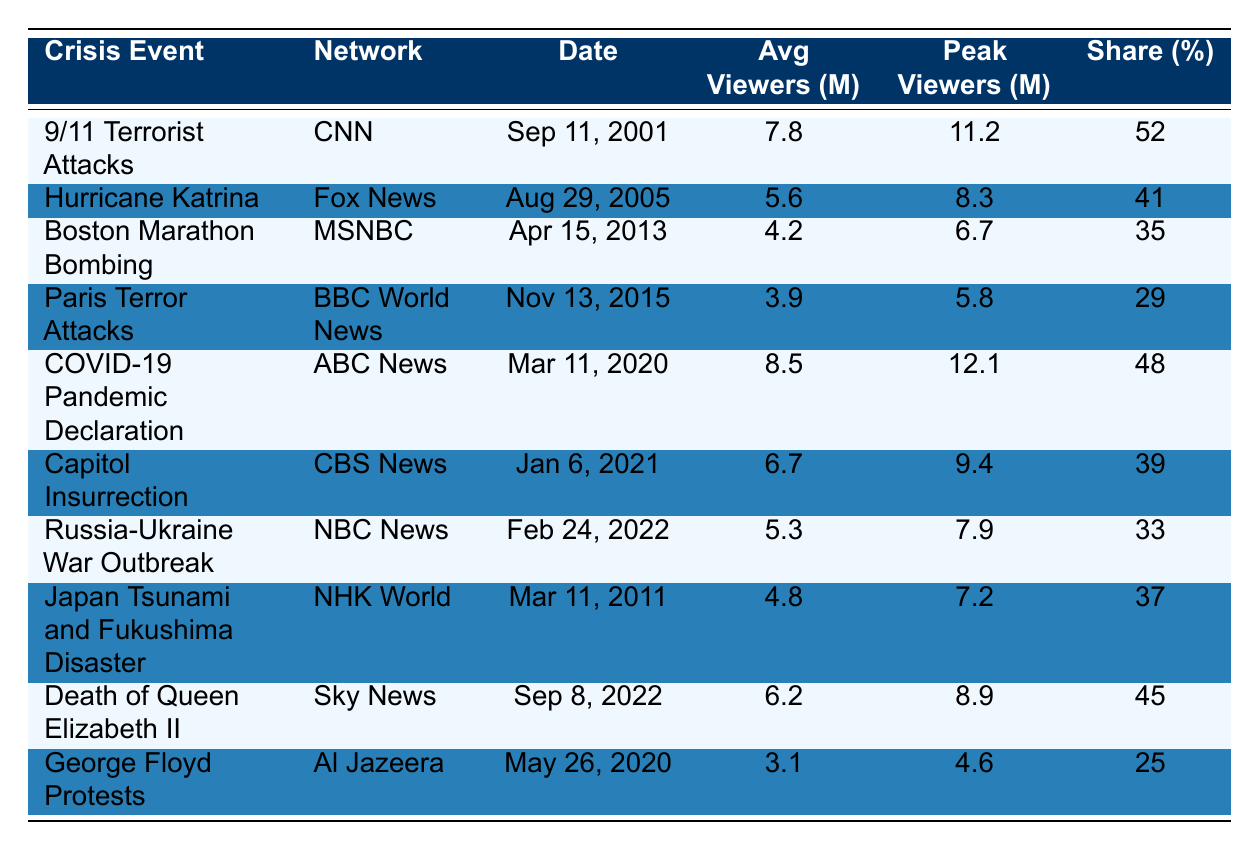What network had the highest average viewer count during a crisis event? According to the table, CNN had the highest average viewer count of 7.8 million during the 9/11 Terrorist Attacks.
Answer: CNN Which crisis event had the lowest peak viewers? The table shows that the George Floyd Protests had the lowest peak viewers at 4.6 million.
Answer: George Floyd Protests What is the average share percentage of viewers for all the crisis events listed? To find the average share percentage, add all the share values (52 + 41 + 35 + 29 + 48 + 39 + 33 + 37 + 45 + 25) = 404 and divide by the number of events (10). Thus, 404/10 = 40.4.
Answer: 40.4 Which crisis event experienced a peak viewership of over 10 million? The COVID-19 Pandemic Declaration reached a peak viewership of 12.1 million, while the 9/11 Terrorist Attacks reached 11.2 million.
Answer: COVID-19 Pandemic Declaration and 9/11 Terrorist Attacks Was the average viewer count during the Hurricane Katrina broadcast higher than that during the Boston Marathon Bombing? The table indicates that Hurricane Katrina had an average viewer count of 5.6 million, while the Boston Marathon Bombing had 4.2 million. Since 5.6 is greater than 4.2, the statement is true.
Answer: Yes How many events had an average viewer count below 5 million? The table lists events with average viewer counts below 5 million: Boston Marathon Bombing (4.2), Paris Terror Attacks (3.9), Japan Tsunami and Fukushima Disaster (4.8), and George Floyd Protests (3.1). There are 4 such events.
Answer: 4 What percentage of viewers did the Capitol Insurrection have compared to the peak viewership of the 9/11 Terrorist Attacks? The Capitol Insurrection had 6.7 million average viewers compared to the peak of 11.2 million for the 9/11 event. To find the percentage, calculate (6.7/11.2) * 100 = 59.82%.
Answer: 59.82% Which event's broadcast had an average viewer count that was more than 5 million but less than 7 million? From the table, the Capitol Insurrection with 6.7 million is the only event that meets this criterion.
Answer: Capitol Insurrection Was there more than one event that had an average viewer count equal to or greater than 6 million? Yes, the 9/11 Terrorist Attacks with 7.8 million and the COVID-19 Pandemic Declaration with 8.5 million both have average counts greater than 6 million.
Answer: Yes What was the average number of viewers for the events shown in 2020? The COVID-19 Pandemic Declaration had 8.5 million and the George Floyd Protests had 3.1 million. Adding these gives 8.5 + 3.1 = 11.6 million. Dividing by 2 (the number of events) results in 11.6 / 2 = 5.8 million.
Answer: 5.8 million 